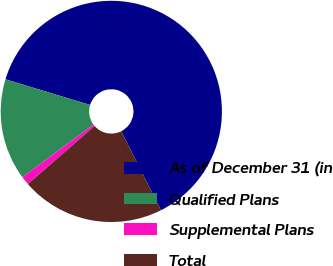Convert chart to OTSL. <chart><loc_0><loc_0><loc_500><loc_500><pie_chart><fcel>As of December 31 (in<fcel>Qualified Plans<fcel>Supplemental Plans<fcel>Total<nl><fcel>62.91%<fcel>14.83%<fcel>1.27%<fcel>21.0%<nl></chart> 